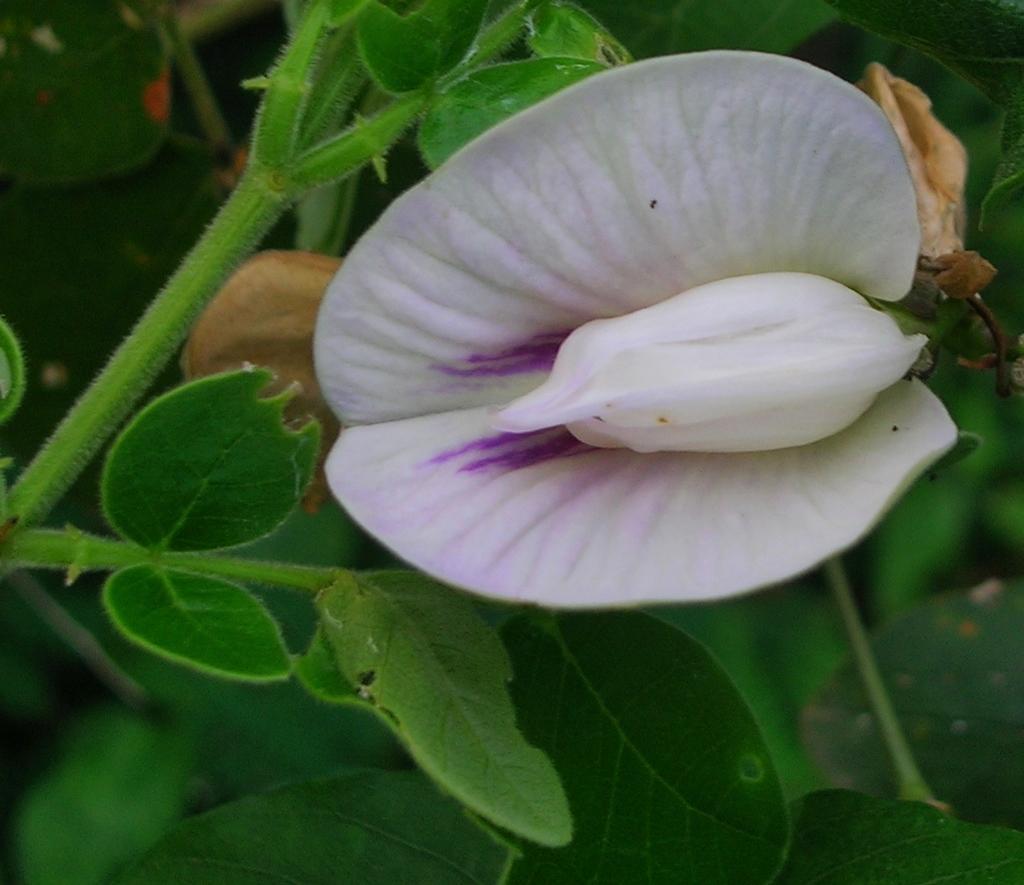Can you describe this image briefly? In this picture we can see a flower and in the background we can see leaves. 